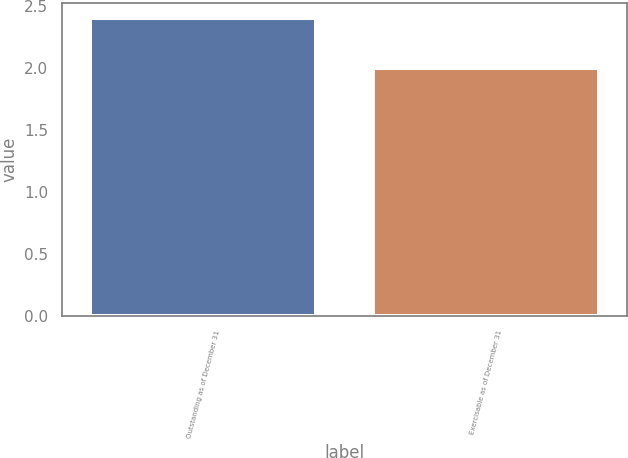<chart> <loc_0><loc_0><loc_500><loc_500><bar_chart><fcel>Outstanding as of December 31<fcel>Exercisable as of December 31<nl><fcel>2.4<fcel>2<nl></chart> 